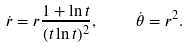<formula> <loc_0><loc_0><loc_500><loc_500>\dot { r } = r \frac { 1 + \ln t } { ( t \ln t ) ^ { 2 } } , \quad \dot { \theta } = r ^ { 2 } .</formula> 